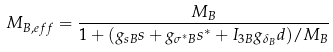Convert formula to latex. <formula><loc_0><loc_0><loc_500><loc_500>M _ { B , e f f } = \frac { M _ { B } } { 1 + ( g _ { s B } s + g _ { \sigma ^ { * } B } s ^ { * } + I _ { 3 B } g _ { \delta _ { B } } d ) / M _ { B } }</formula> 